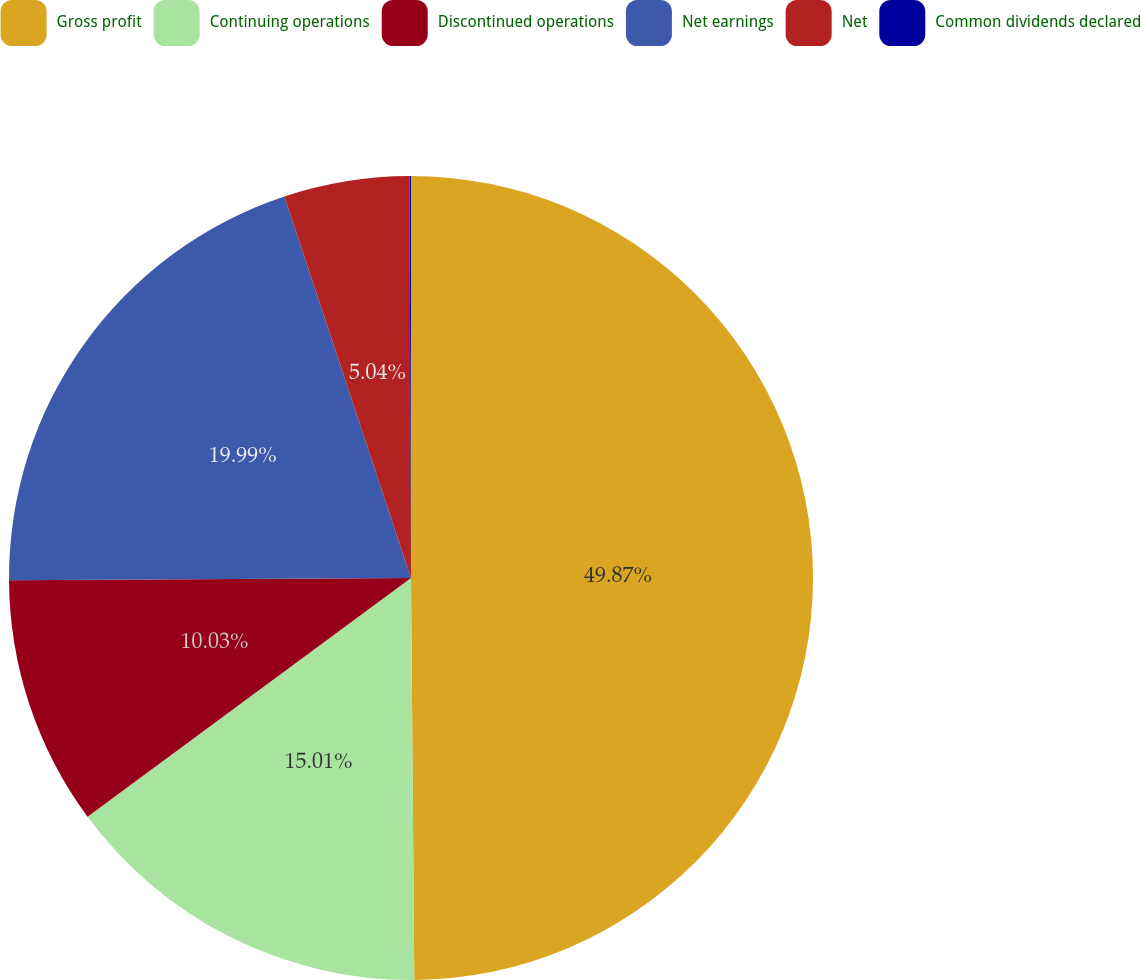<chart> <loc_0><loc_0><loc_500><loc_500><pie_chart><fcel>Gross profit<fcel>Continuing operations<fcel>Discontinued operations<fcel>Net earnings<fcel>Net<fcel>Common dividends declared<nl><fcel>49.87%<fcel>15.01%<fcel>10.03%<fcel>19.99%<fcel>5.04%<fcel>0.06%<nl></chart> 